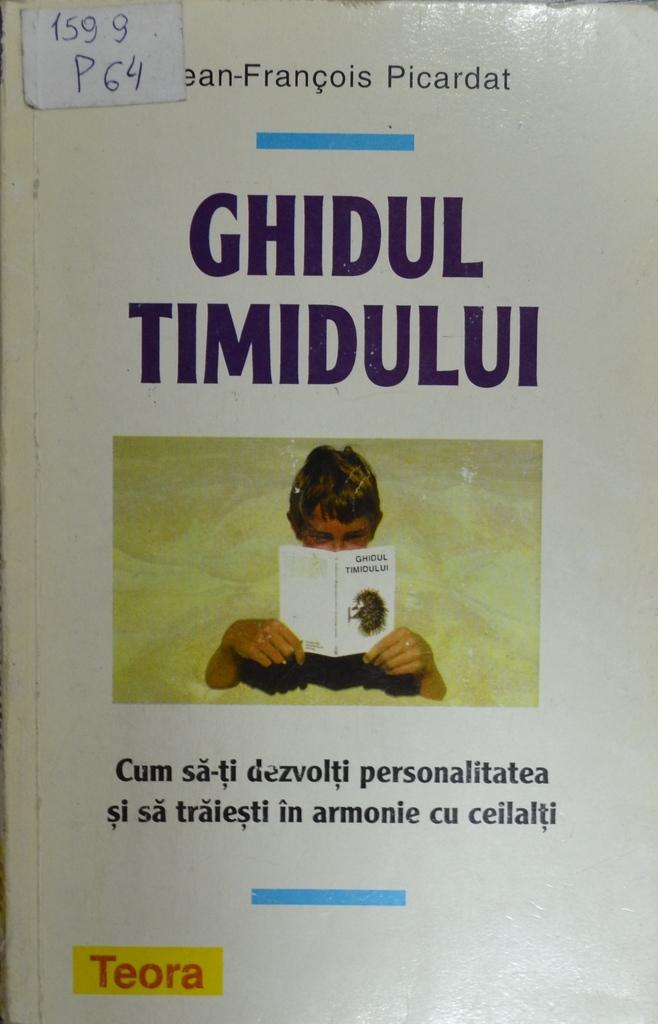What is the title of the book?
Make the answer very short. Ghidul timidului. What is the numerical number written in the slip ?
Your answer should be very brief. 1599. 